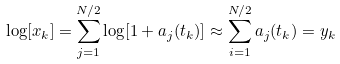<formula> <loc_0><loc_0><loc_500><loc_500>\log [ x _ { k } ] = \sum _ { j = 1 } ^ { N / 2 } \log [ 1 + a _ { j } ( t _ { k } ) ] \approx \sum _ { i = 1 } ^ { N / 2 } a _ { j } ( t _ { k } ) = y _ { k }</formula> 